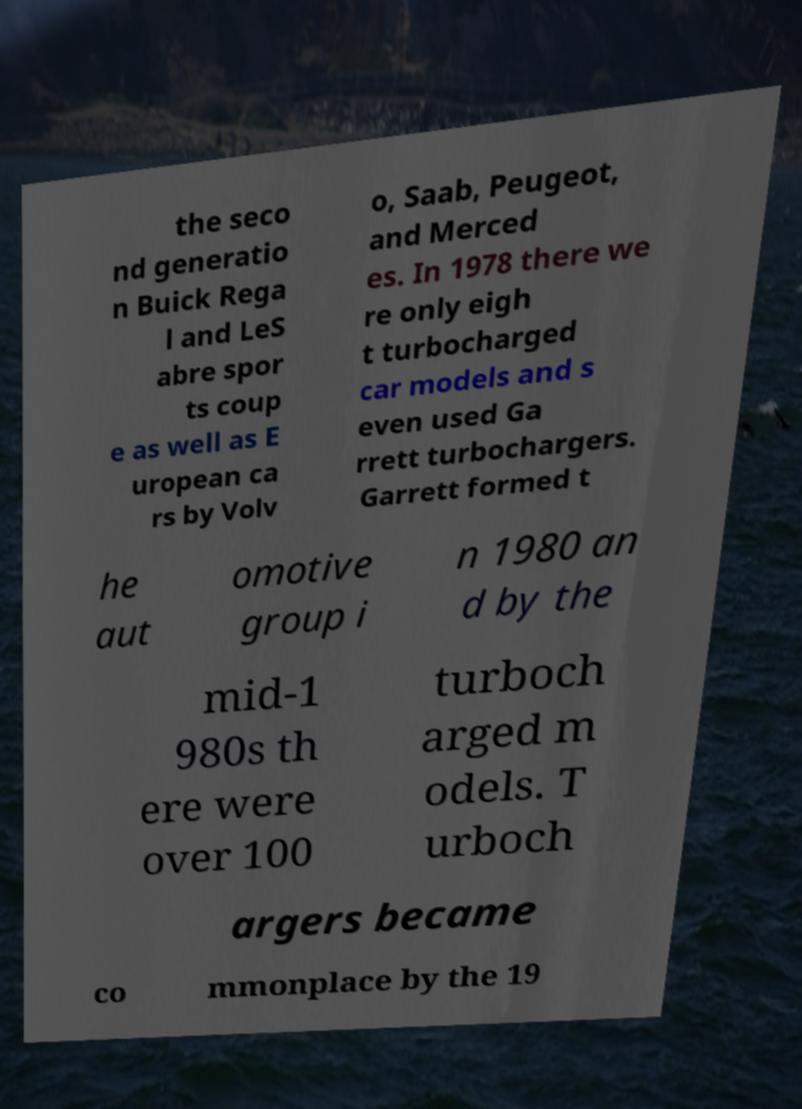Could you extract and type out the text from this image? the seco nd generatio n Buick Rega l and LeS abre spor ts coup e as well as E uropean ca rs by Volv o, Saab, Peugeot, and Merced es. In 1978 there we re only eigh t turbocharged car models and s even used Ga rrett turbochargers. Garrett formed t he aut omotive group i n 1980 an d by the mid-1 980s th ere were over 100 turboch arged m odels. T urboch argers became co mmonplace by the 19 